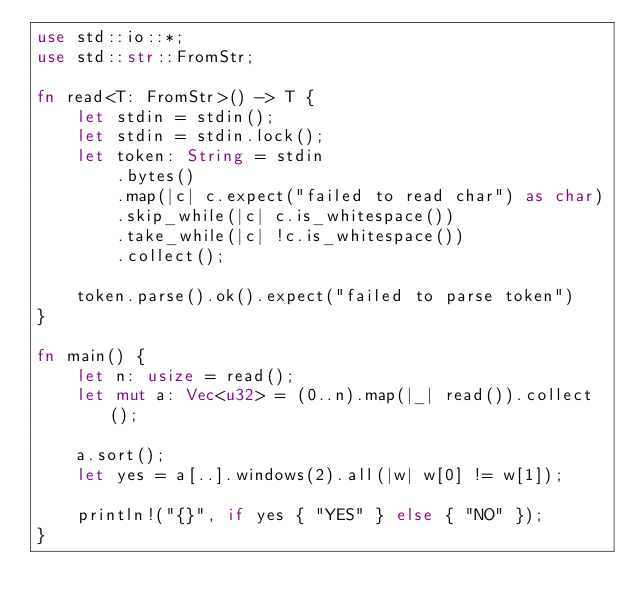<code> <loc_0><loc_0><loc_500><loc_500><_Rust_>use std::io::*;
use std::str::FromStr;

fn read<T: FromStr>() -> T {
    let stdin = stdin();
    let stdin = stdin.lock();
    let token: String = stdin
        .bytes()
        .map(|c| c.expect("failed to read char") as char)
        .skip_while(|c| c.is_whitespace())
        .take_while(|c| !c.is_whitespace())
        .collect();

    token.parse().ok().expect("failed to parse token")
}

fn main() {
    let n: usize = read();
    let mut a: Vec<u32> = (0..n).map(|_| read()).collect();

    a.sort();
    let yes = a[..].windows(2).all(|w| w[0] != w[1]);

    println!("{}", if yes { "YES" } else { "NO" });
}
</code> 